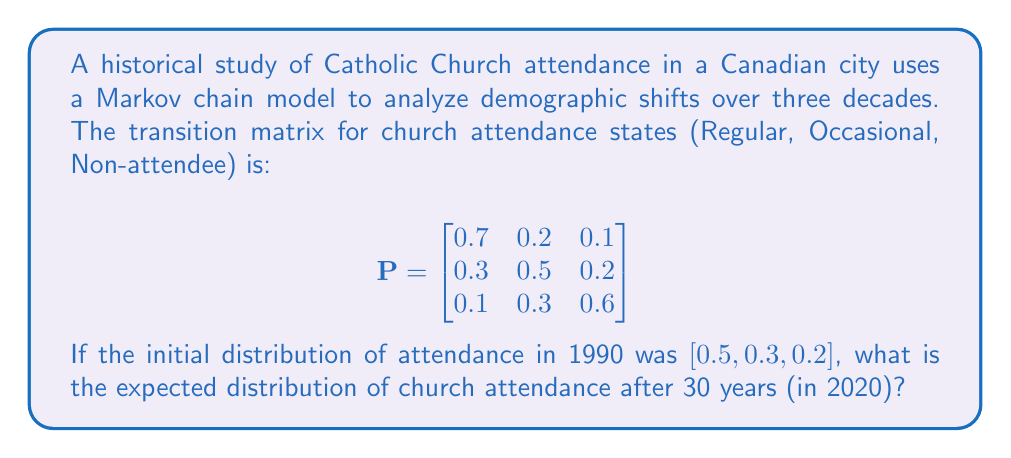What is the answer to this math problem? To solve this problem, we need to use the properties of Markov chains and matrix multiplication. The steps are as follows:

1) The initial distribution is given as a row vector:
   $$\pi_0 = [0.5, 0.3, 0.2]$$

2) To find the distribution after 30 years, we need to multiply the initial distribution by the transition matrix 30 times:
   $$\pi_{30} = \pi_0 \cdot P^{30}$$

3) However, calculating $P^{30}$ directly would be computationally intensive. Instead, we can use the fact that for a regular Markov chain, the distribution converges to a stationary distribution as the number of steps increases.

4) To find the stationary distribution $\pi$, we solve the equation:
   $$\pi = \pi P$$

5) This is equivalent to solving:
   $$\pi (P - I) = 0$$
   where $I$ is the 3x3 identity matrix.

6) We also know that the components of $\pi$ must sum to 1:
   $$\pi_1 + \pi_2 + \pi_3 = 1$$

7) Solving this system of equations:
   $$\begin{align}
   0.3\pi_1 - 0.2\pi_2 - 0.1\pi_3 &= 0 \\
   -0.3\pi_1 + 0.5\pi_2 - 0.3\pi_3 &= 0 \\
   \pi_1 + \pi_2 + \pi_3 &= 1
   \end{align}$$

8) The solution to this system is:
   $$\pi = [0.2857, 0.3571, 0.3571]$$

9) After 30 years, the distribution will be very close to this stationary distribution.
Answer: The expected distribution of church attendance after 30 years (in 2020) is approximately:

Regular attendees: 28.57%
Occasional attendees: 35.71%
Non-attendees: 35.71%

or in vector form: $[0.2857, 0.3571, 0.3571]$ 